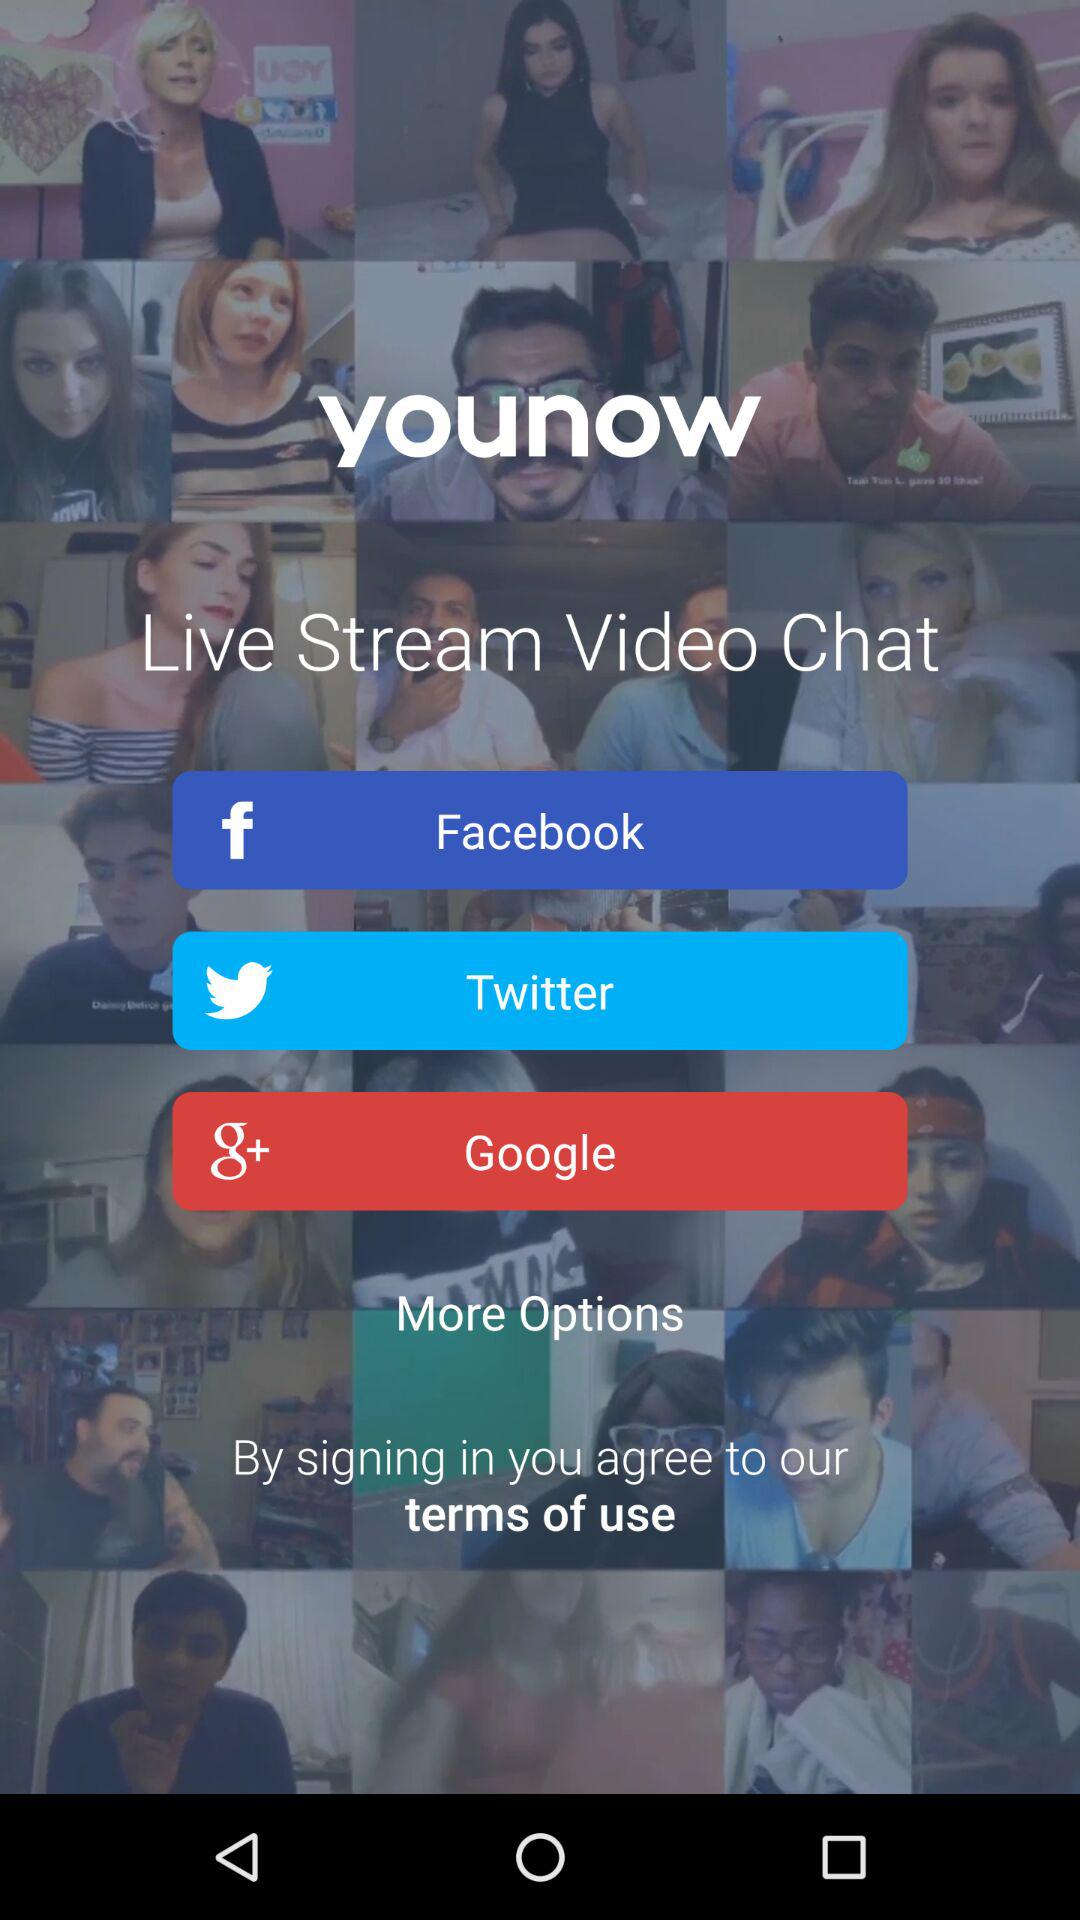What are the sign-in options? The sign-in options are "Facebook", "Twitter" and "Google". 